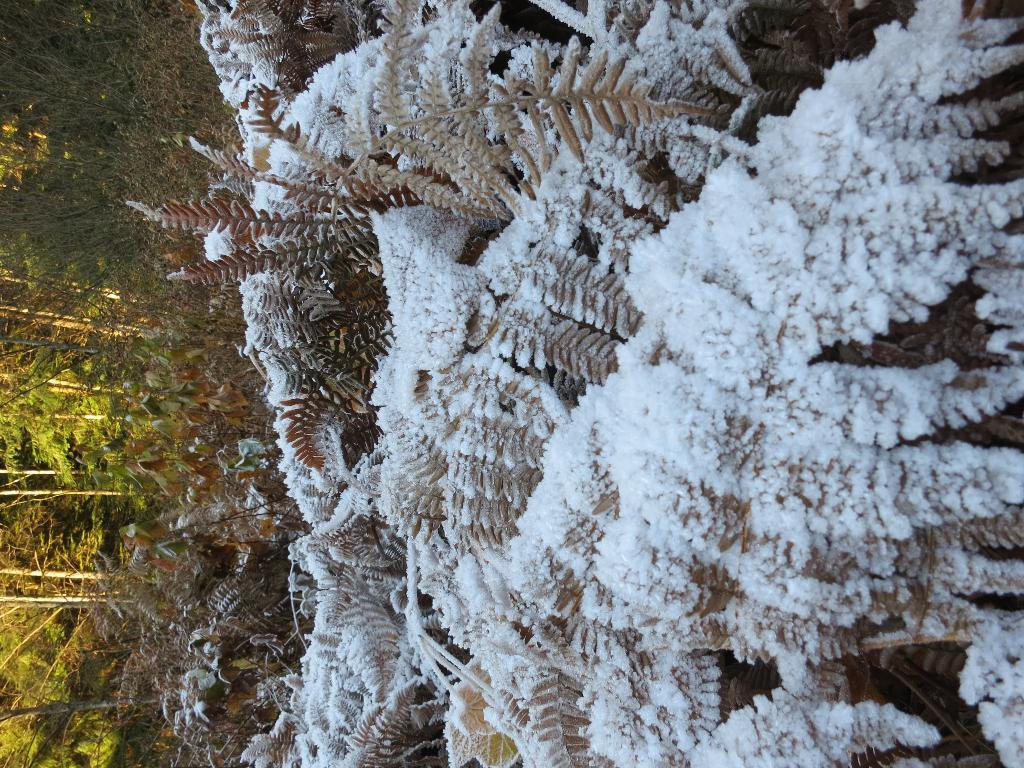What type of vegetation can be seen in the image? There are trees and plants in the image. Can you describe the specific types of plants in the image? The provided facts do not specify the types of plants, only that there are plants in the image. What type of advertisement can be seen on the drum in the image? There is no drum or advertisement present in the image. How many cows are visible in the image? There are no cows present in the image. 